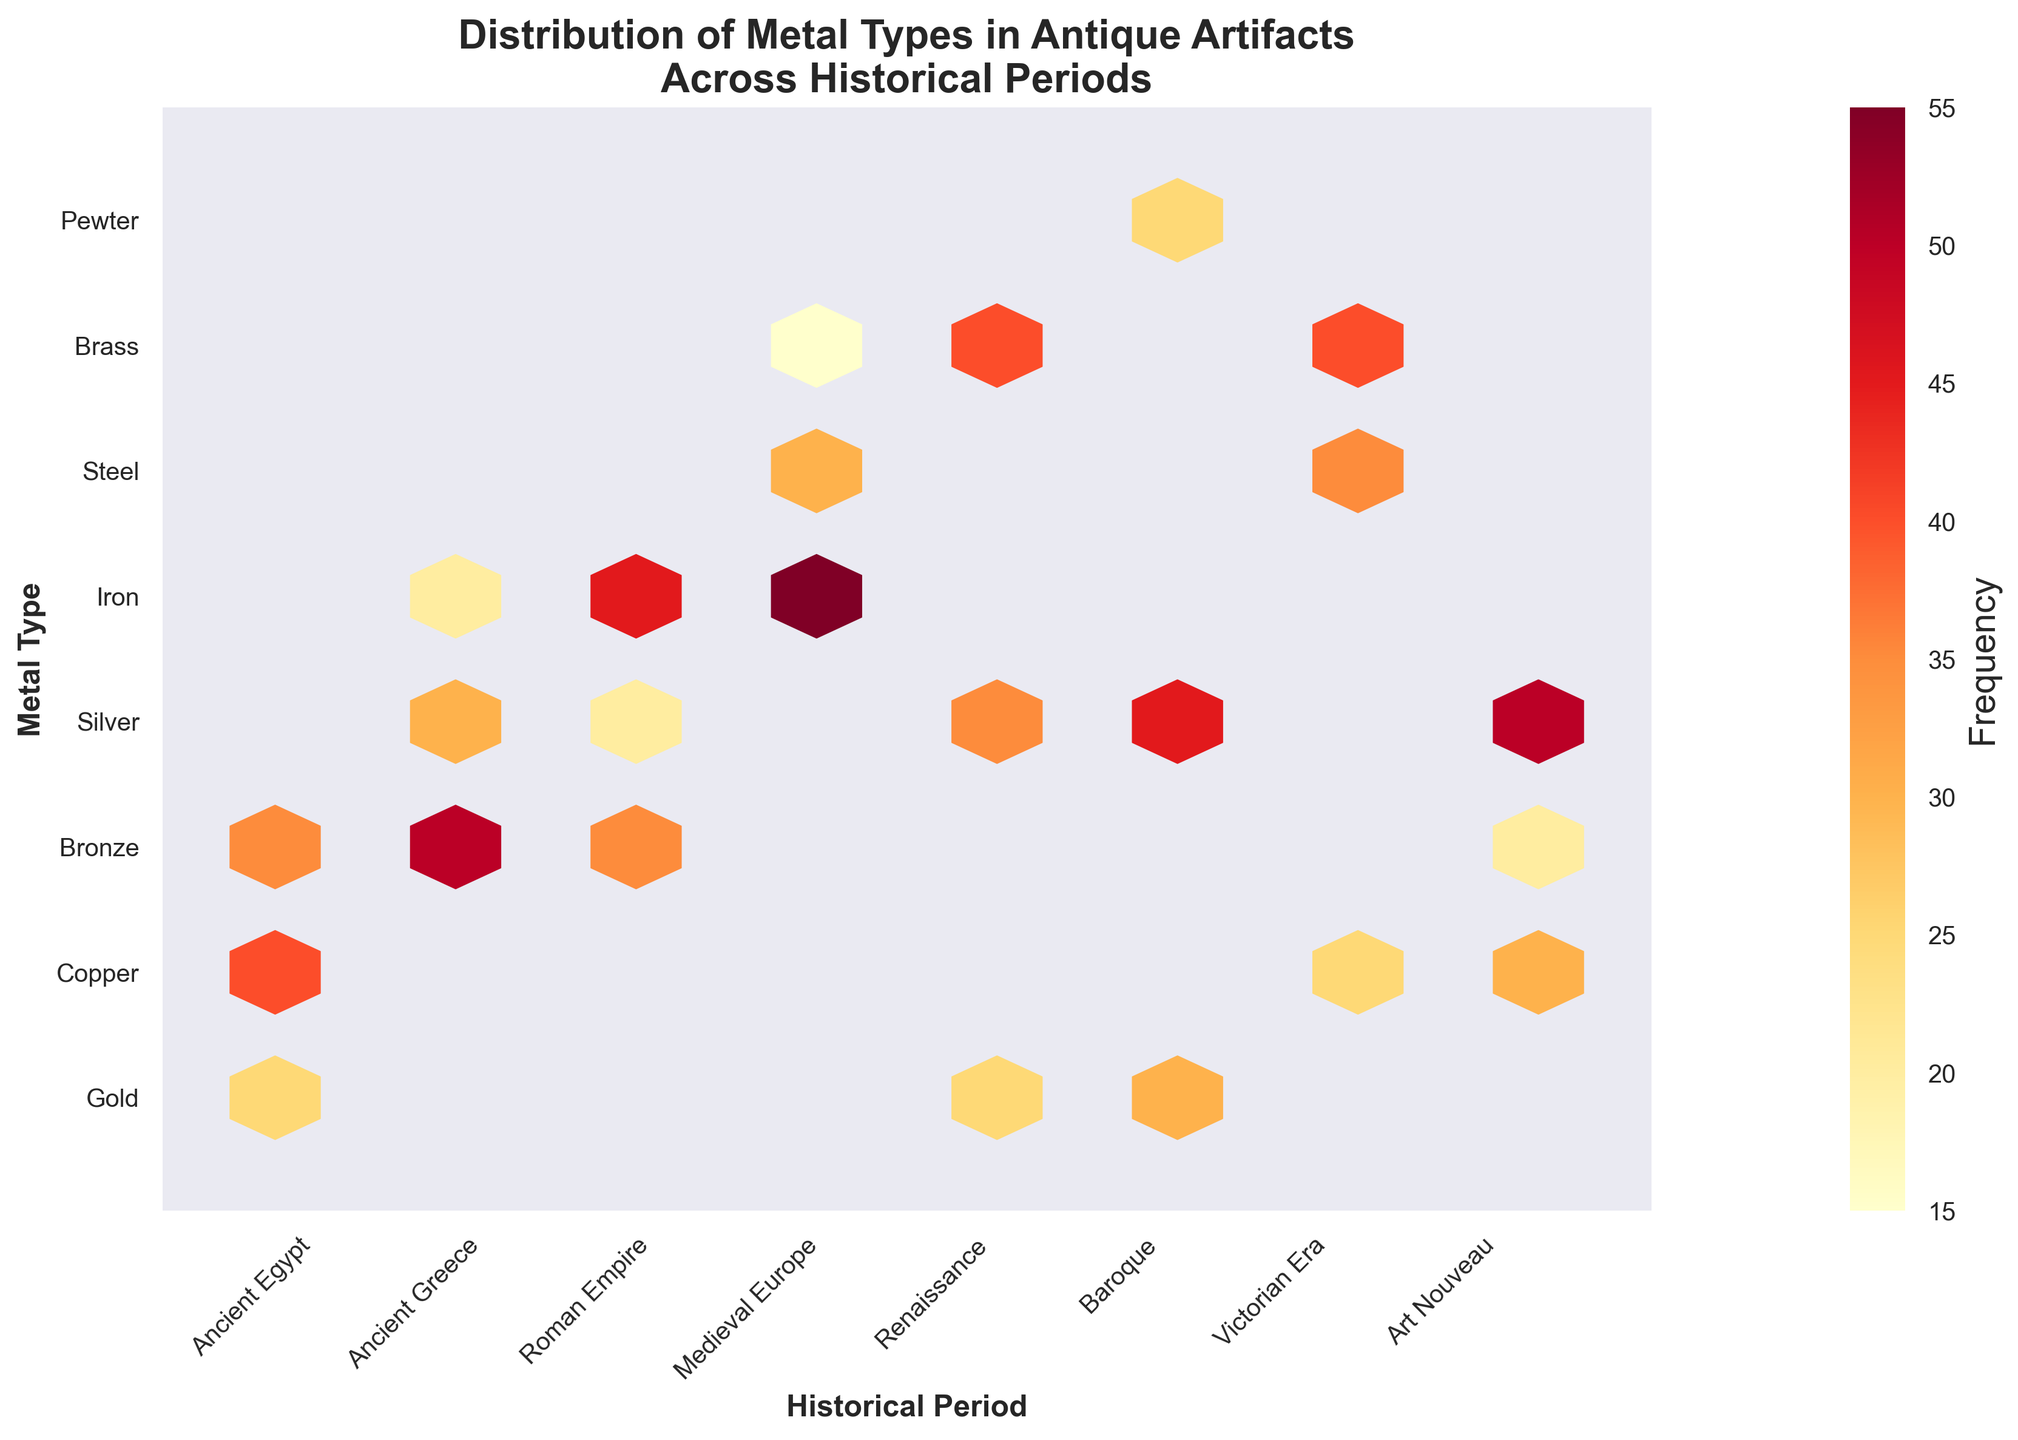How many different metal types are shown in the plot? Count the number of different y-tick labels representing the metal types.
Answer: 11 What historical period had the highest frequency of silver artifacts? Look for the bin with the highest frequency on the hexbin color scale and match it with the historical period along the x-axis and the metal type along the y-axis.
Answer: Art Nouveau Which metal type appears most frequently during the Baroque period? Locate the Baroque period along the x-axis and find the metal type with the darkest hexbin, referring to the color scale for frequency.
Answer: Silver Compare the frequency of Bronze artifacts in Ancient Greece and the Roman Empire. Which period had more Bronze artifacts? Locate the Bronze y-tick and compare the respective hexbin colors for Ancient Greece and the Roman Empire using the color scale.
Answer: Ancient Greece What is the average frequency of Copper artifacts across all periods? Sum the frequencies of Copper artifacts across all periods and divide by the number of periods with Copper artifacts.
Answer: (40 + 25 + 30) / 3 = 31.67 During which historical periods was Iron the most used metal type? Identify the periods where Iron's frequency hexbin is the darkest compared to other metals' hexbins in the same period.
Answer: Medieval Europe and the Roman Empire What is the total frequency of Gold artifacts across all historical periods? Add up the frequencies of Gold artifacts for each period where Gold appears.
Answer: 25 + 25 + 30 = 80 Which metal type had the widest distribution across different historical periods? Determine the metal type represented by the most number of hexbins on the y-axis.
Answer: Bronze How does the distribution of Steel artifacts in the Medieval period compare to the Victorian Era? Compare the color intensity of the hexbins representing Steel artifacts in both periods using the color scale.
Answer: Medieval Europe had fewer Steel artifacts than the Victorian Era What historical period had the highest diversity of metal types used in artifacts? Identify the period along the x-axis with the most y-ticks having corresponding hexbins.
Answer: Ancient Greece 